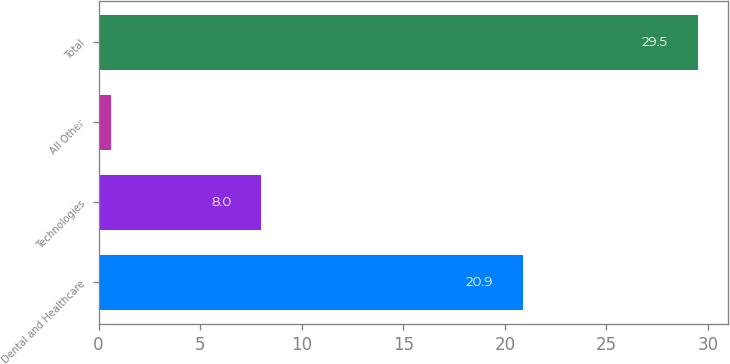Convert chart to OTSL. <chart><loc_0><loc_0><loc_500><loc_500><bar_chart><fcel>Dental and Healthcare<fcel>Technologies<fcel>All Other<fcel>Total<nl><fcel>20.9<fcel>8<fcel>0.6<fcel>29.5<nl></chart> 